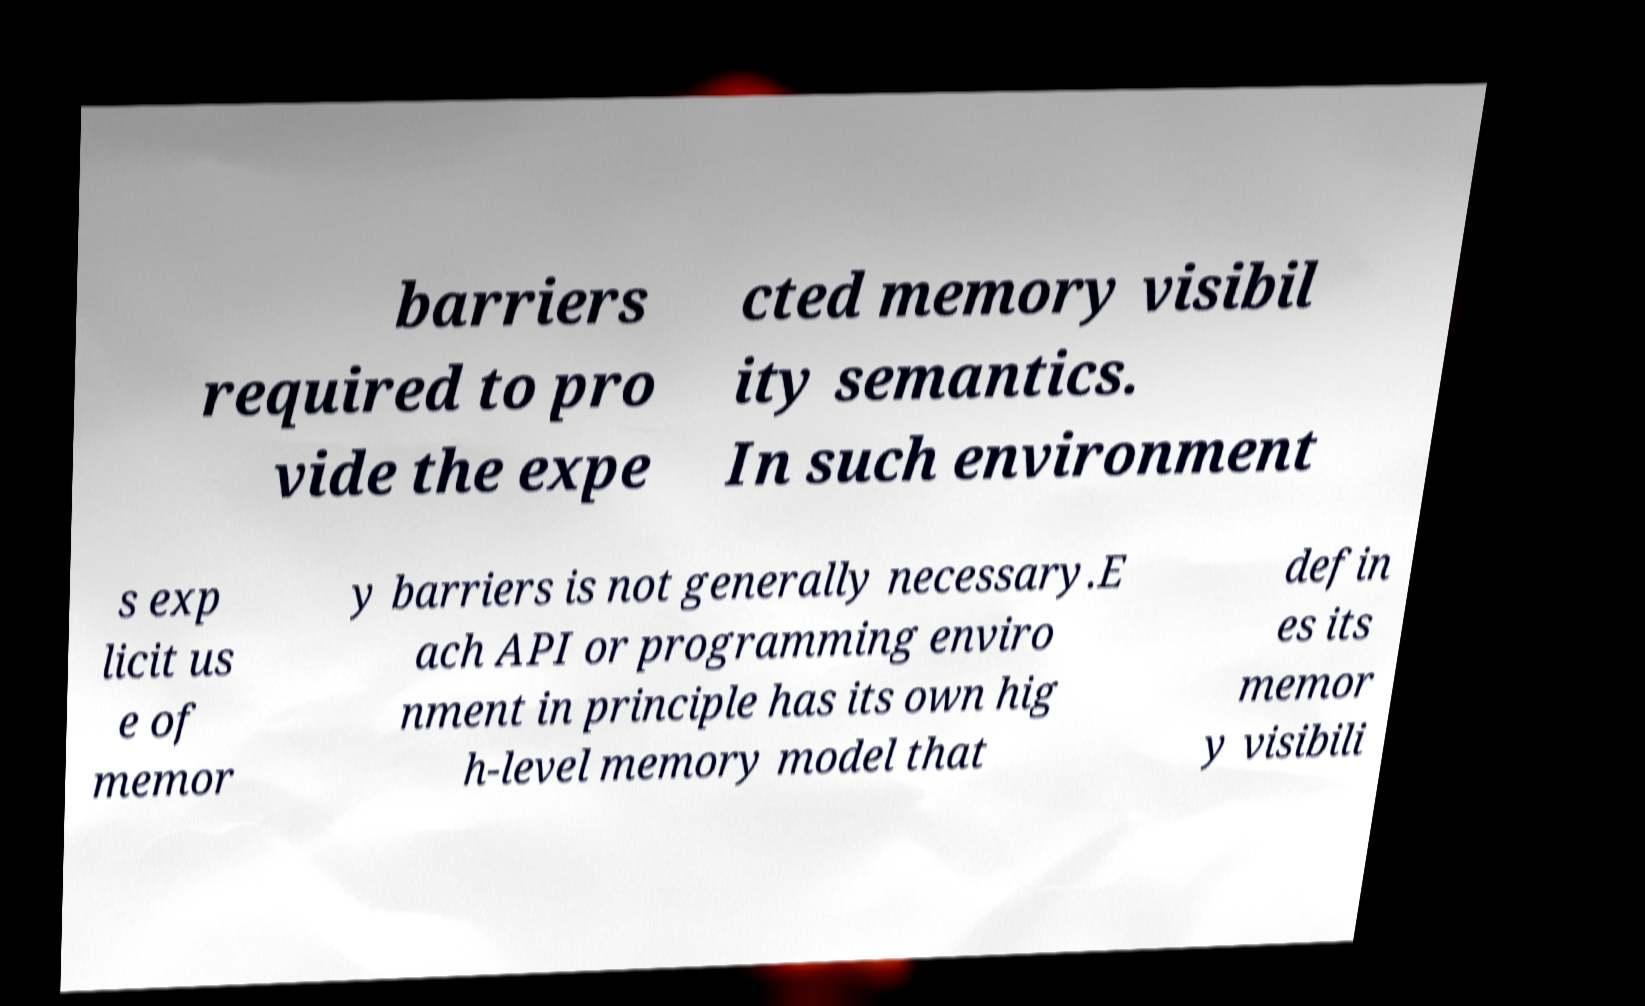Could you extract and type out the text from this image? barriers required to pro vide the expe cted memory visibil ity semantics. In such environment s exp licit us e of memor y barriers is not generally necessary.E ach API or programming enviro nment in principle has its own hig h-level memory model that defin es its memor y visibili 